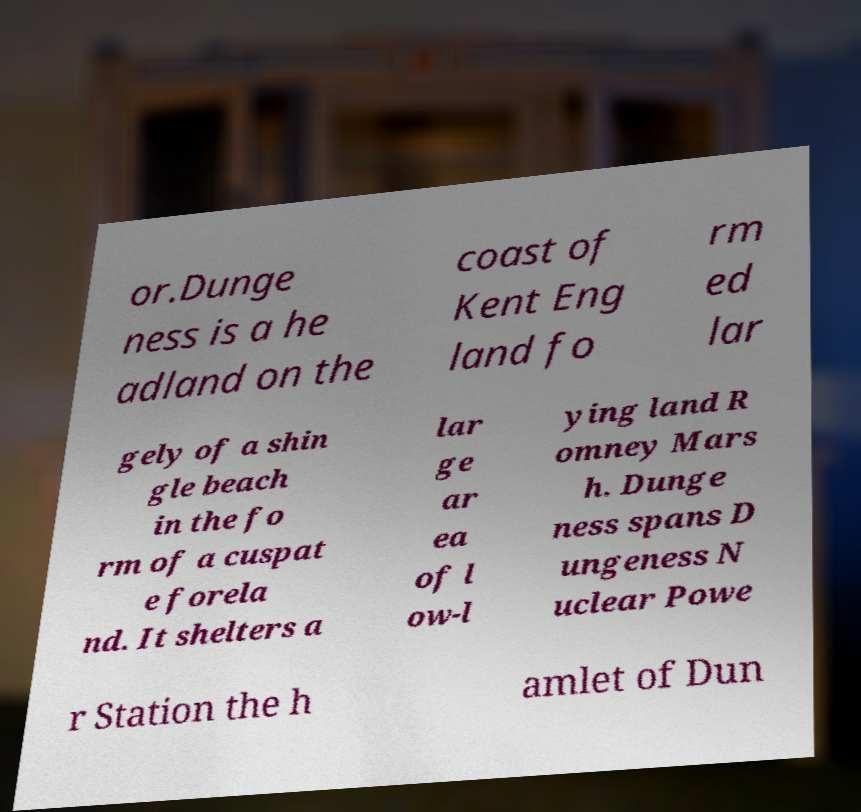What messages or text are displayed in this image? I need them in a readable, typed format. or.Dunge ness is a he adland on the coast of Kent Eng land fo rm ed lar gely of a shin gle beach in the fo rm of a cuspat e forela nd. It shelters a lar ge ar ea of l ow-l ying land R omney Mars h. Dunge ness spans D ungeness N uclear Powe r Station the h amlet of Dun 